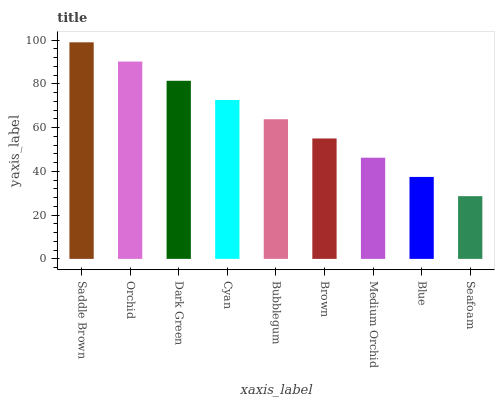Is Seafoam the minimum?
Answer yes or no. Yes. Is Saddle Brown the maximum?
Answer yes or no. Yes. Is Orchid the minimum?
Answer yes or no. No. Is Orchid the maximum?
Answer yes or no. No. Is Saddle Brown greater than Orchid?
Answer yes or no. Yes. Is Orchid less than Saddle Brown?
Answer yes or no. Yes. Is Orchid greater than Saddle Brown?
Answer yes or no. No. Is Saddle Brown less than Orchid?
Answer yes or no. No. Is Bubblegum the high median?
Answer yes or no. Yes. Is Bubblegum the low median?
Answer yes or no. Yes. Is Seafoam the high median?
Answer yes or no. No. Is Medium Orchid the low median?
Answer yes or no. No. 